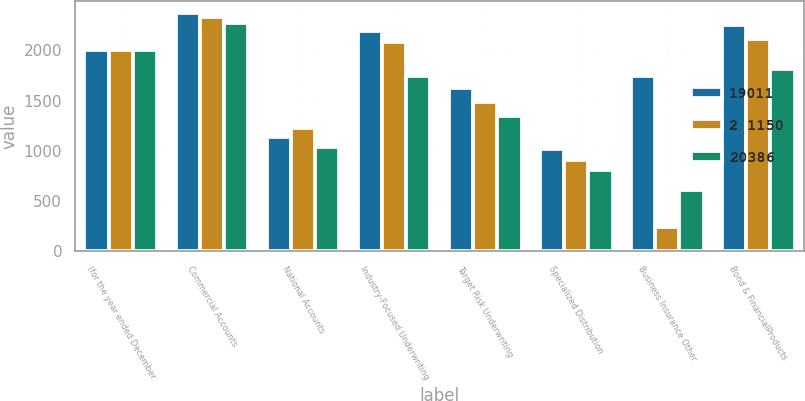Convert chart. <chart><loc_0><loc_0><loc_500><loc_500><stacked_bar_chart><ecel><fcel>(for the year ended December<fcel>Commercial Accounts<fcel>National Accounts<fcel>Industry-Focused Underwriting<fcel>Target Risk Underwriting<fcel>Specialized Distribution<fcel>Business Insurance Other<fcel>Bond & FinancialProducts<nl><fcel>19011<fcel>2006<fcel>2376<fcel>1135<fcel>2196<fcel>1629<fcel>1022<fcel>1747<fcel>2255<nl><fcel>2 1150<fcel>2005<fcel>2330<fcel>1230<fcel>2080<fcel>1482<fcel>908<fcel>247<fcel>2117<nl><fcel>20386<fcel>2004<fcel>2273<fcel>1040<fcel>1747<fcel>1345<fcel>807<fcel>607<fcel>1819<nl></chart> 